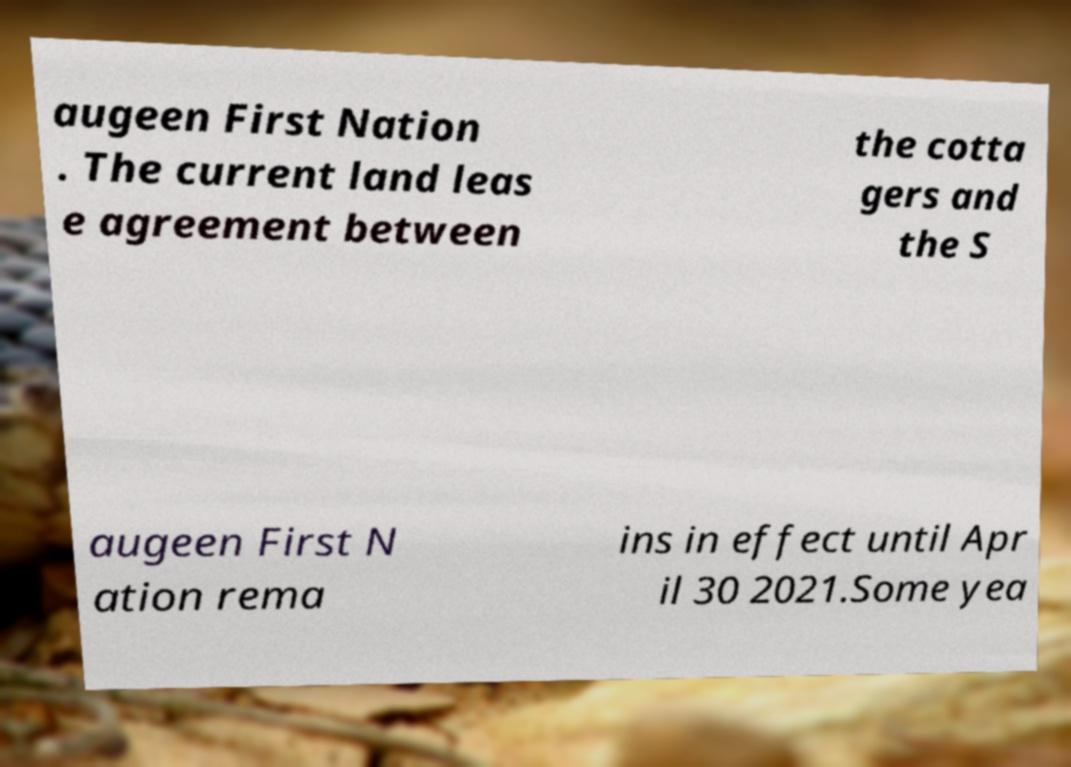What messages or text are displayed in this image? I need them in a readable, typed format. augeen First Nation . The current land leas e agreement between the cotta gers and the S augeen First N ation rema ins in effect until Apr il 30 2021.Some yea 